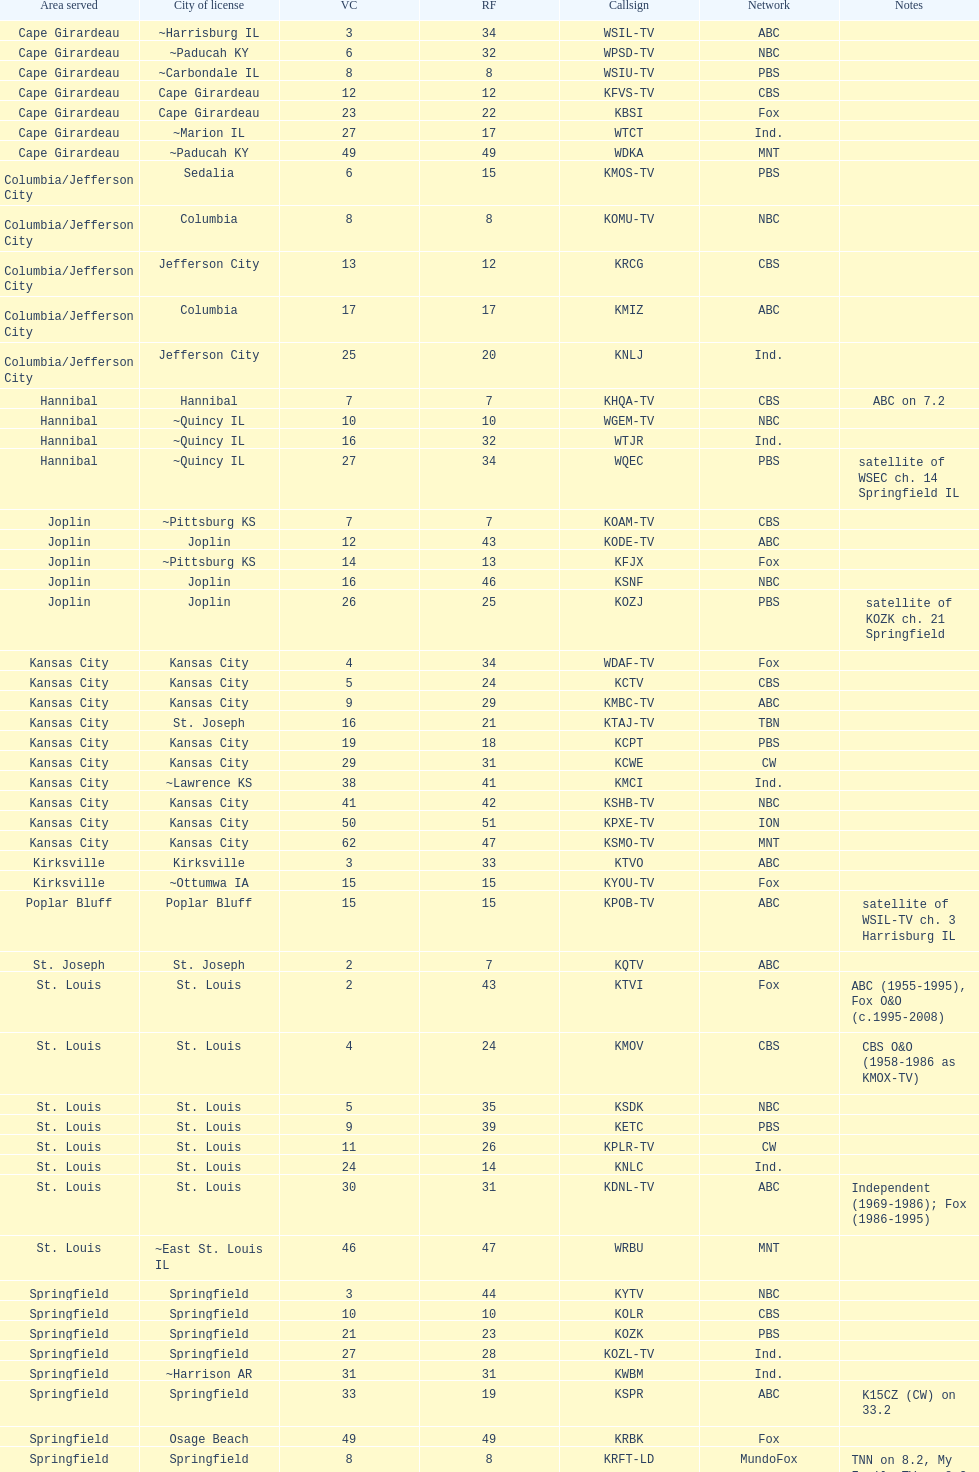What is the total number of stations under the cbs network? 7. 